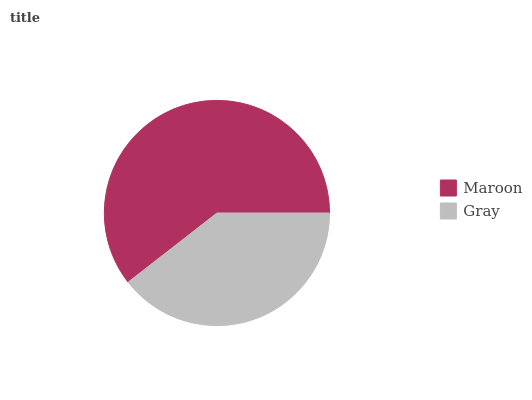Is Gray the minimum?
Answer yes or no. Yes. Is Maroon the maximum?
Answer yes or no. Yes. Is Gray the maximum?
Answer yes or no. No. Is Maroon greater than Gray?
Answer yes or no. Yes. Is Gray less than Maroon?
Answer yes or no. Yes. Is Gray greater than Maroon?
Answer yes or no. No. Is Maroon less than Gray?
Answer yes or no. No. Is Maroon the high median?
Answer yes or no. Yes. Is Gray the low median?
Answer yes or no. Yes. Is Gray the high median?
Answer yes or no. No. Is Maroon the low median?
Answer yes or no. No. 